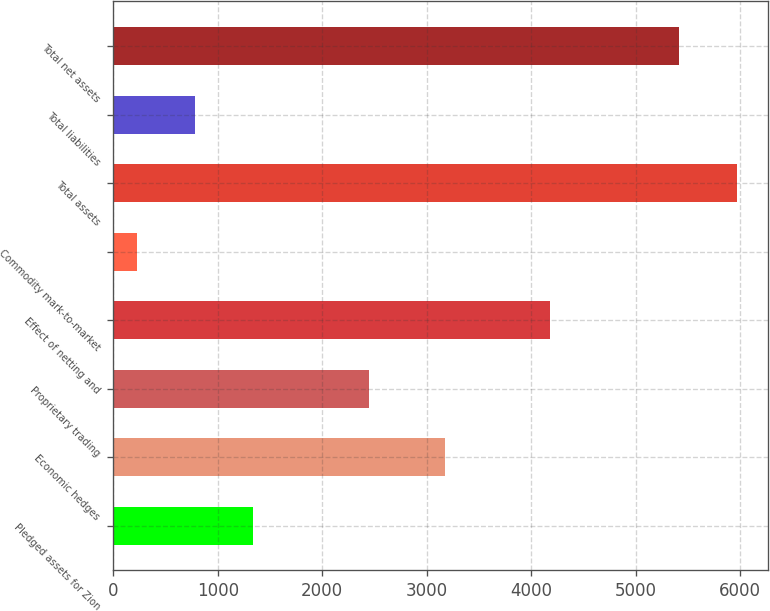Convert chart. <chart><loc_0><loc_0><loc_500><loc_500><bar_chart><fcel>Pledged assets for Zion<fcel>Economic hedges<fcel>Proprietary trading<fcel>Effect of netting and<fcel>Commodity mark-to-market<fcel>Total assets<fcel>Total liabilities<fcel>Total net assets<nl><fcel>1338<fcel>3173<fcel>2448<fcel>4175<fcel>228<fcel>5970<fcel>783<fcel>5415<nl></chart> 